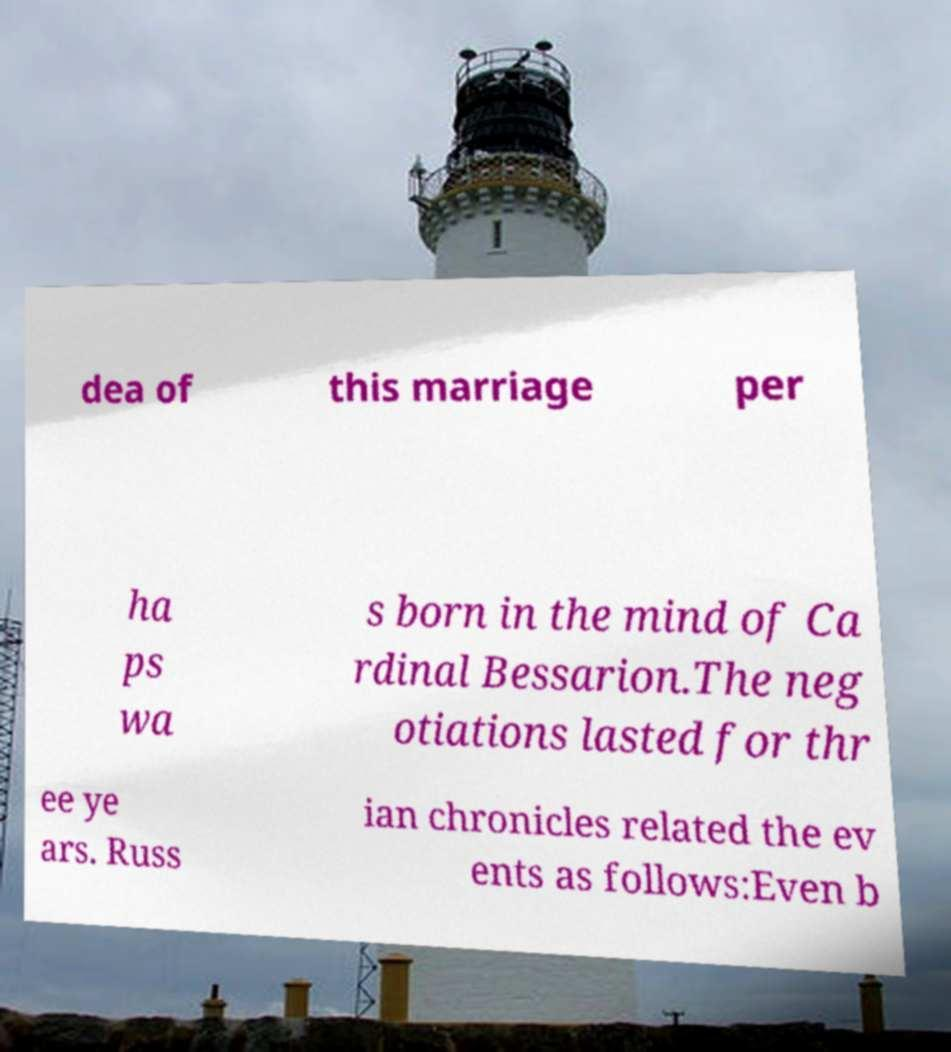I need the written content from this picture converted into text. Can you do that? dea of this marriage per ha ps wa s born in the mind of Ca rdinal Bessarion.The neg otiations lasted for thr ee ye ars. Russ ian chronicles related the ev ents as follows:Even b 